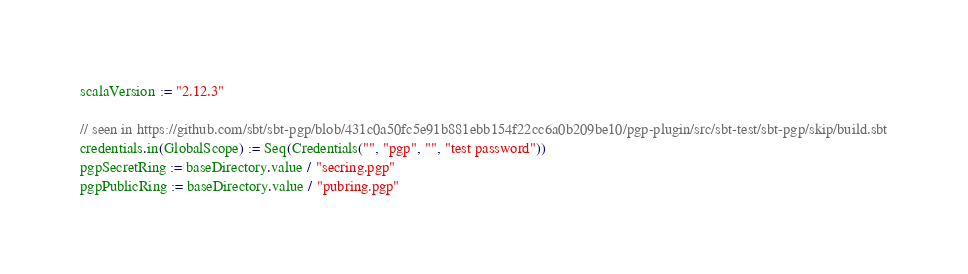<code> <loc_0><loc_0><loc_500><loc_500><_Scala_>scalaVersion := "2.12.3"

// seen in https://github.com/sbt/sbt-pgp/blob/431c0a50fc5e91b881ebb154f22cc6a0b209be10/pgp-plugin/src/sbt-test/sbt-pgp/skip/build.sbt
credentials.in(GlobalScope) := Seq(Credentials("", "pgp", "", "test password"))
pgpSecretRing := baseDirectory.value / "secring.pgp"
pgpPublicRing := baseDirectory.value / "pubring.pgp"
</code> 